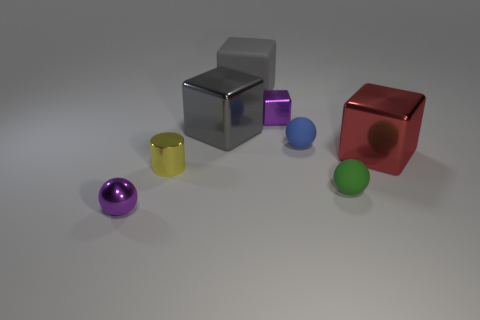Add 1 tiny gray matte things. How many objects exist? 9 Subtract all spheres. How many objects are left? 5 Subtract all small objects. Subtract all tiny purple things. How many objects are left? 1 Add 1 large rubber blocks. How many large rubber blocks are left? 2 Add 6 small metallic things. How many small metallic things exist? 9 Subtract 0 cyan cylinders. How many objects are left? 8 